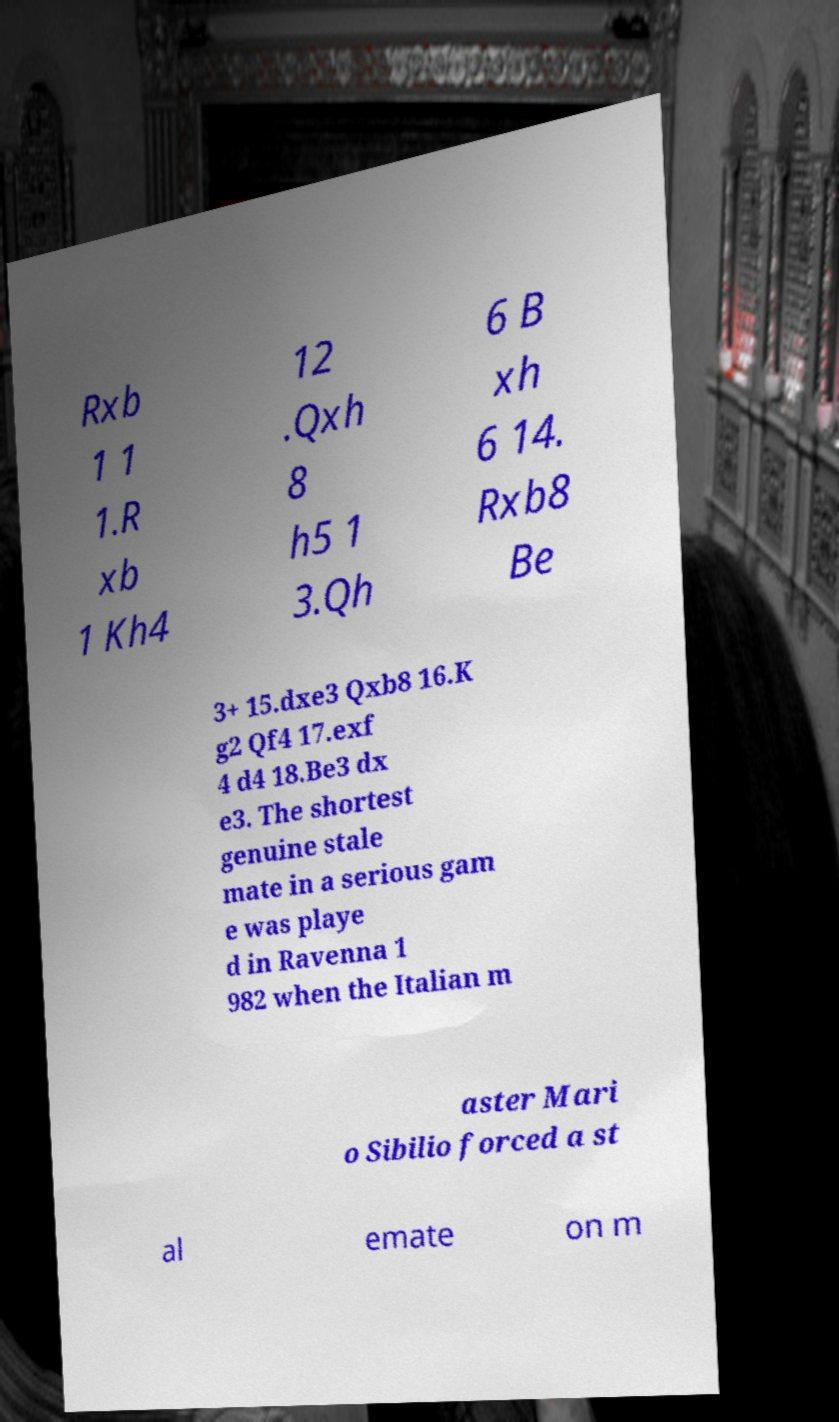Please identify and transcribe the text found in this image. Rxb 1 1 1.R xb 1 Kh4 12 .Qxh 8 h5 1 3.Qh 6 B xh 6 14. Rxb8 Be 3+ 15.dxe3 Qxb8 16.K g2 Qf4 17.exf 4 d4 18.Be3 dx e3. The shortest genuine stale mate in a serious gam e was playe d in Ravenna 1 982 when the Italian m aster Mari o Sibilio forced a st al emate on m 